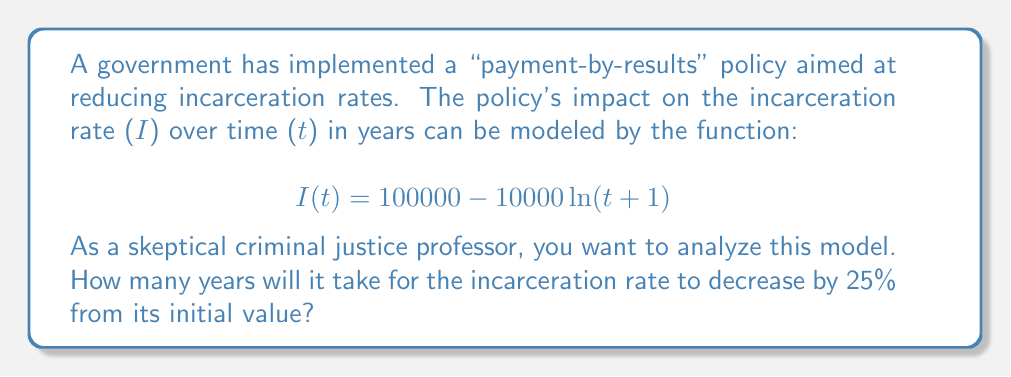Give your solution to this math problem. Let's approach this step-by-step:

1) First, we need to find the initial incarceration rate (at t = 0):
   $$I(0) = 100000 - 10000 \ln(0+1) = 100000 - 10000 \ln(1) = 100000$$

2) We want to find when the rate has decreased by 25%, so we're looking for:
   $$I(t) = 100000 \cdot 0.75 = 75000$$

3) Now we can set up our equation:
   $$75000 = 100000 - 10000 \ln(t+1)$$

4) Subtract 100000 from both sides:
   $$-25000 = -10000 \ln(t+1)$$

5) Divide both sides by -10000:
   $$2.5 = \ln(t+1)$$

6) Apply $e^x$ to both sides:
   $$e^{2.5} = t+1$$

7) Subtract 1 from both sides:
   $$e^{2.5} - 1 = t$$

8) Calculate the value:
   $$t \approx 11.18$$

9) Since we can't have a fractional year in this context, we round up to the next whole year.
Answer: 12 years 